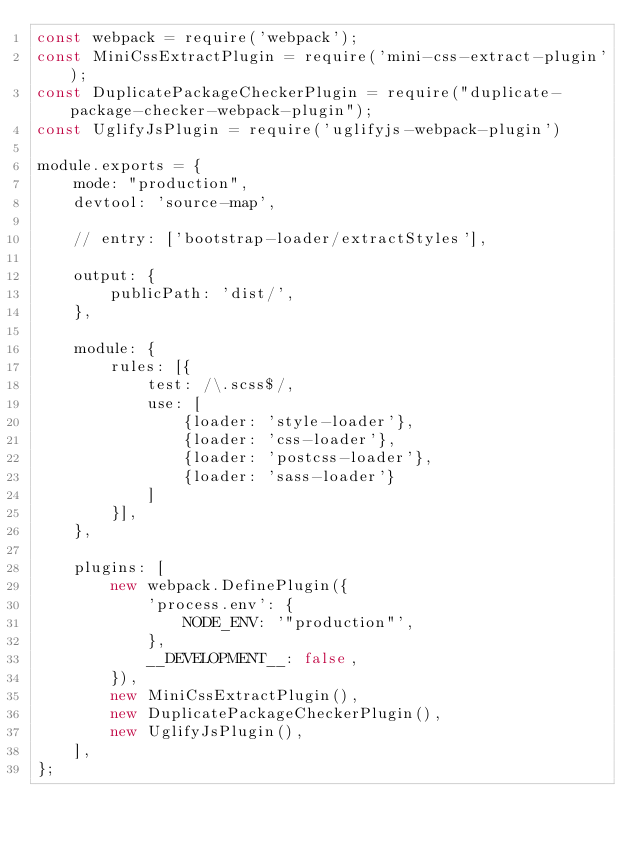<code> <loc_0><loc_0><loc_500><loc_500><_JavaScript_>const webpack = require('webpack');
const MiniCssExtractPlugin = require('mini-css-extract-plugin');
const DuplicatePackageCheckerPlugin = require("duplicate-package-checker-webpack-plugin");
const UglifyJsPlugin = require('uglifyjs-webpack-plugin')

module.exports = {
    mode: "production",
    devtool: 'source-map',

    // entry: ['bootstrap-loader/extractStyles'],

    output: {
        publicPath: 'dist/',
    },

    module: {
        rules: [{
            test: /\.scss$/,
            use: [
                {loader: 'style-loader'},
                {loader: 'css-loader'},
                {loader: 'postcss-loader'},
                {loader: 'sass-loader'}
            ]
        }],
    },

    plugins: [
        new webpack.DefinePlugin({
            'process.env': {
                NODE_ENV: '"production"',
            },
            __DEVELOPMENT__: false,
        }),
        new MiniCssExtractPlugin(),
        new DuplicatePackageCheckerPlugin(),
        new UglifyJsPlugin(),
    ],
};
</code> 